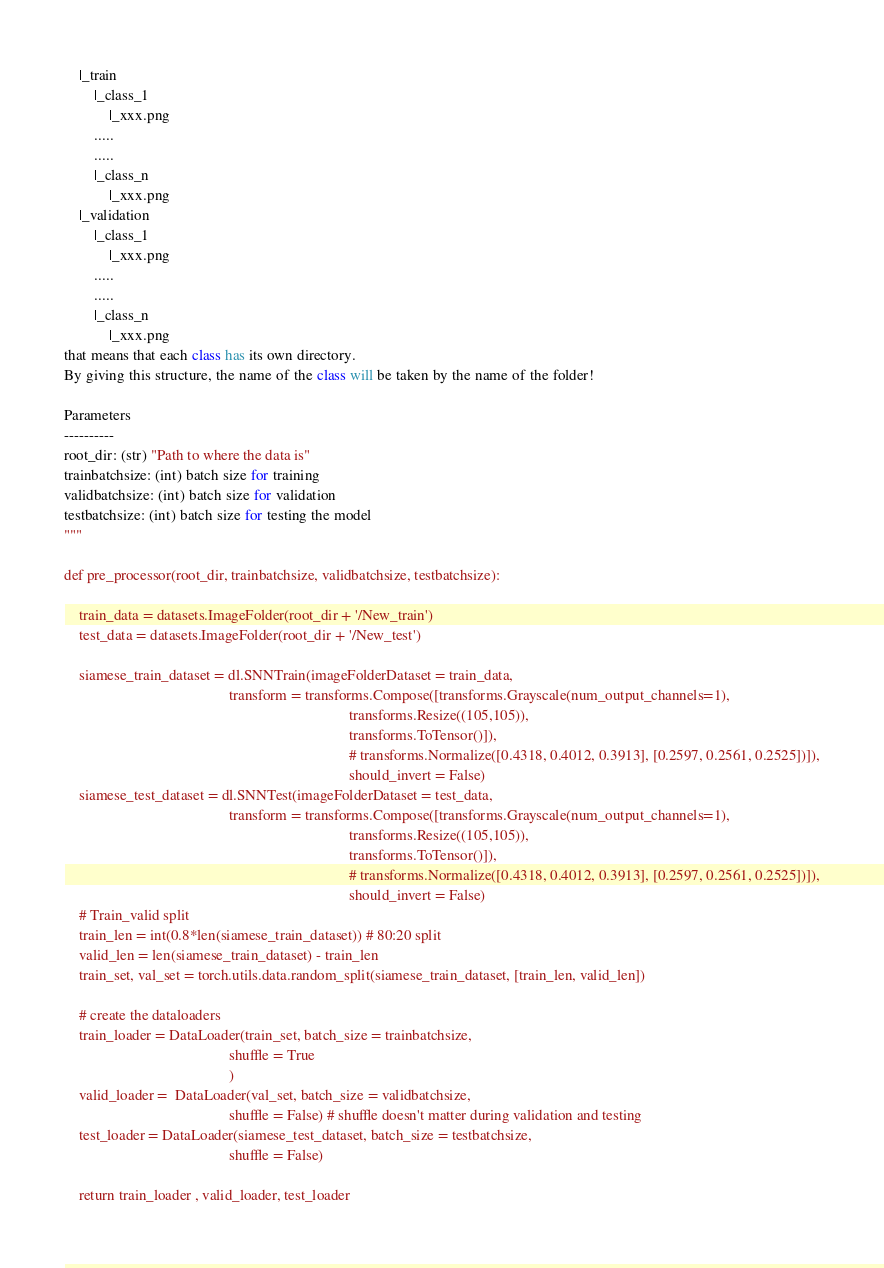<code> <loc_0><loc_0><loc_500><loc_500><_Python_>    |_train
        |_class_1
            |_xxx.png
        .....
        .....    
        |_class_n
            |_xxx.png
    |_validation
        |_class_1
            |_xxx.png
        .....
        .....
        |_class_n
            |_xxx.png
that means that each class has its own directory.
By giving this structure, the name of the class will be taken by the name of the folder!

Parameters
----------
root_dir: (str) "Path to where the data is"
trainbatchsize: (int) batch size for training
validbatchsize: (int) batch size for validation
testbatchsize: (int) batch size for testing the model
"""

def pre_processor(root_dir, trainbatchsize, validbatchsize, testbatchsize):

    train_data = datasets.ImageFolder(root_dir + '/New_train')
    test_data = datasets.ImageFolder(root_dir + '/New_test')

    siamese_train_dataset = dl.SNNTrain(imageFolderDataset = train_data,
                                            transform = transforms.Compose([transforms.Grayscale(num_output_channels=1),
                                                                            transforms.Resize((105,105)),
                                                                            transforms.ToTensor()]),
                                                                            # transforms.Normalize([0.4318, 0.4012, 0.3913], [0.2597, 0.2561, 0.2525])]),
                                                                            should_invert = False)
    siamese_test_dataset = dl.SNNTest(imageFolderDataset = test_data,
                                            transform = transforms.Compose([transforms.Grayscale(num_output_channels=1),
                                                                            transforms.Resize((105,105)),
                                                                            transforms.ToTensor()]),
                                                                            # transforms.Normalize([0.4318, 0.4012, 0.3913], [0.2597, 0.2561, 0.2525])]),
                                                                            should_invert = False)
    # Train_valid split                                                                        
    train_len = int(0.8*len(siamese_train_dataset)) # 80:20 split
    valid_len = len(siamese_train_dataset) - train_len
    train_set, val_set = torch.utils.data.random_split(siamese_train_dataset, [train_len, valid_len])

    # create the dataloaders
    train_loader = DataLoader(train_set, batch_size = trainbatchsize,
                                            shuffle = True
                                            )
    valid_loader =  DataLoader(val_set, batch_size = validbatchsize,
                                            shuffle = False) # shuffle doesn't matter during validation and testing 
    test_loader = DataLoader(siamese_test_dataset, batch_size = testbatchsize,
                                            shuffle = False)

    return train_loader , valid_loader, test_loader
</code> 